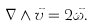Convert formula to latex. <formula><loc_0><loc_0><loc_500><loc_500>\nabla \wedge \vec { v } = 2 \vec { \omega } .</formula> 